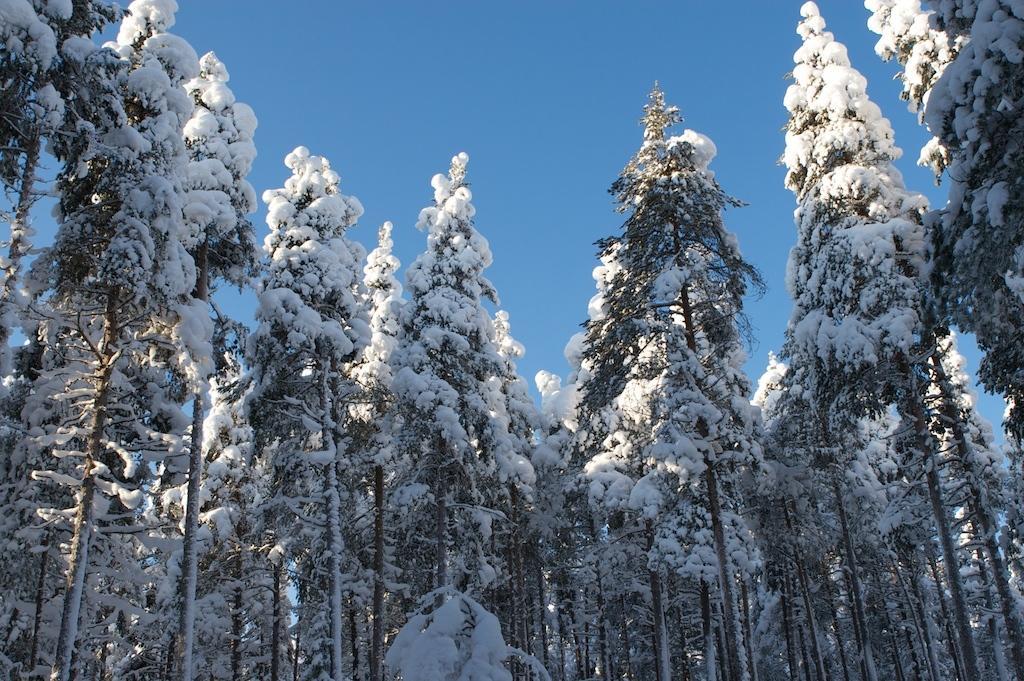In one or two sentences, can you explain what this image depicts? In the picture I can see the trees and there is a snow on the trees. The sky is cloudy. 